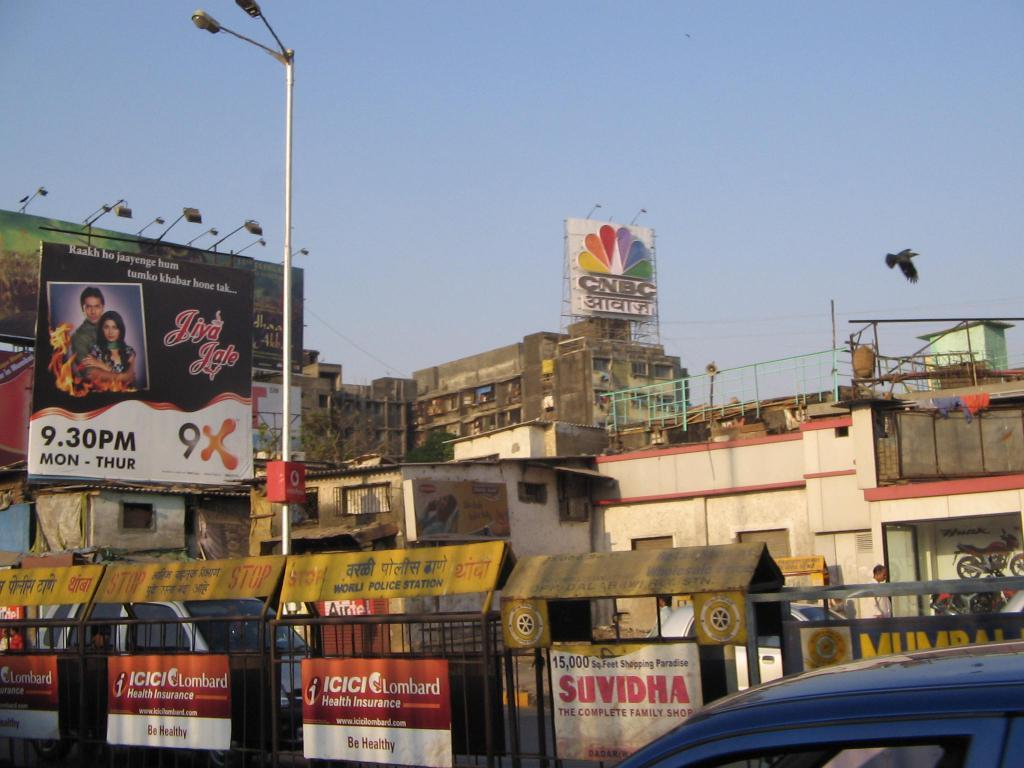<image>
Relay a brief, clear account of the picture shown. A city with a sign for the network CNBC 